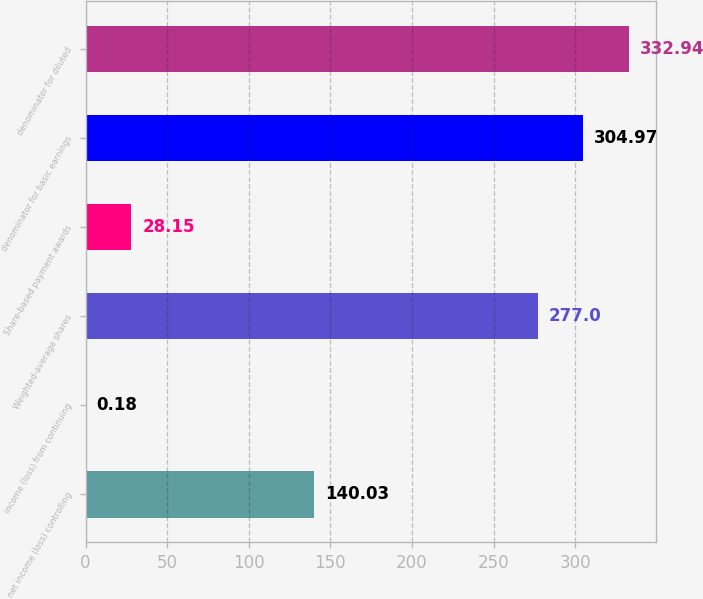<chart> <loc_0><loc_0><loc_500><loc_500><bar_chart><fcel>net income (loss) controlling<fcel>income (loss) from continuing<fcel>Weighted-average shares<fcel>Share-based payment awards<fcel>denominator for basic earnings<fcel>denominator for diluted<nl><fcel>140.03<fcel>0.18<fcel>277<fcel>28.15<fcel>304.97<fcel>332.94<nl></chart> 